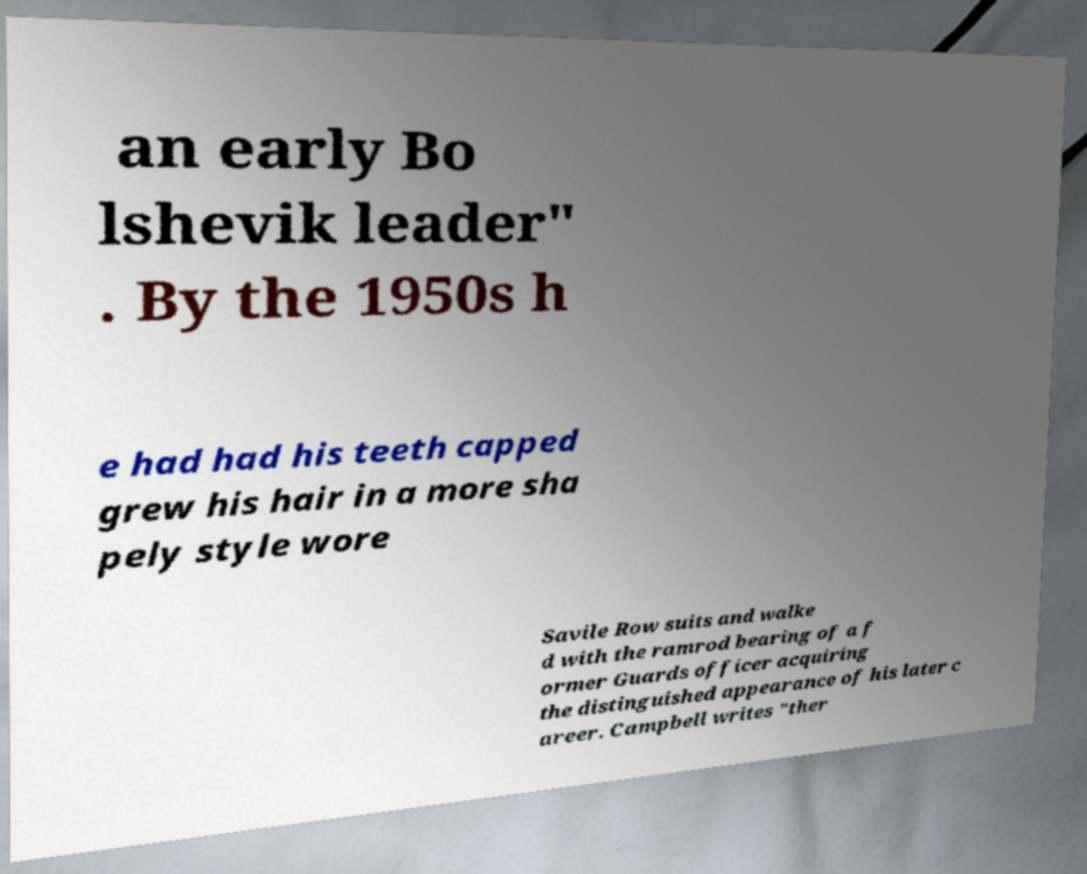Please identify and transcribe the text found in this image. an early Bo lshevik leader" . By the 1950s h e had had his teeth capped grew his hair in a more sha pely style wore Savile Row suits and walke d with the ramrod bearing of a f ormer Guards officer acquiring the distinguished appearance of his later c areer. Campbell writes "ther 